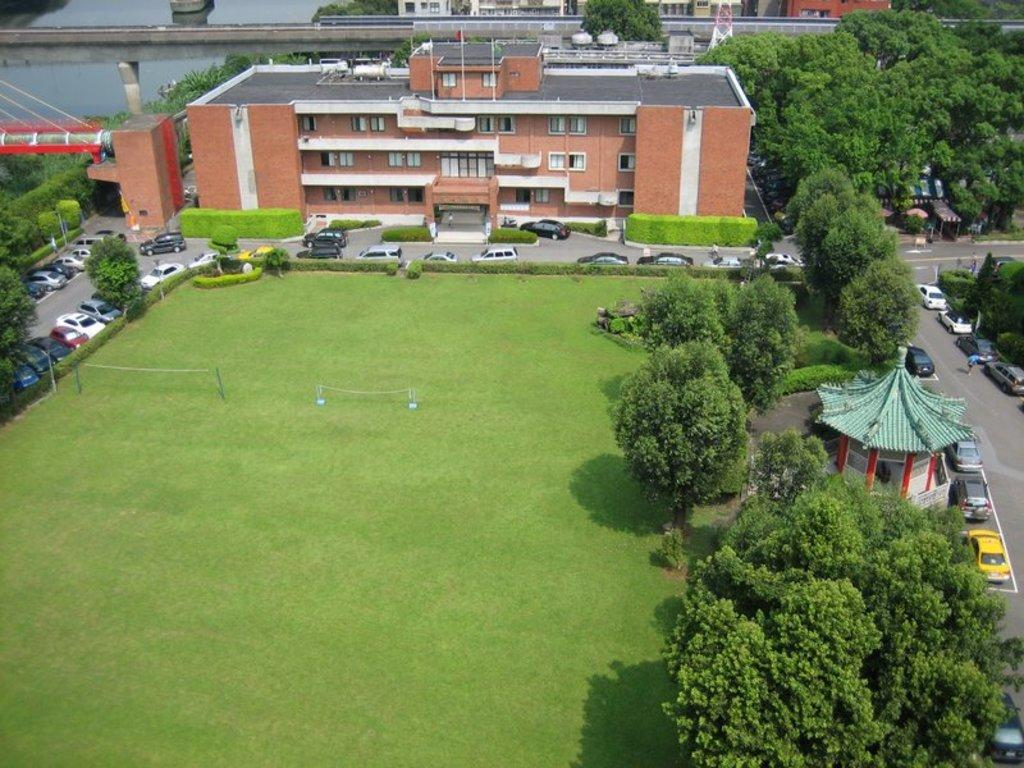What type of vegetation can be seen in the image? There is grass in the image. What structures are present in the image? There are nets, buildings, and a tower visible in the image. What type of transportation can be seen in the image? There are vehicles in the image. What natural features are present in the image? There are trees in the image. What man-made structures can be seen in the background of the image? In the background, there is a tower and a bridge over the water. What type of action or reaction can be seen in the wind in the image? There is no wind present in the image, so no action or reaction can be observed. 